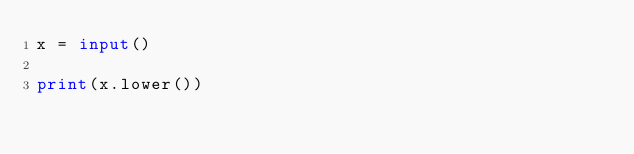Convert code to text. <code><loc_0><loc_0><loc_500><loc_500><_Python_>x = input()

print(x.lower())</code> 